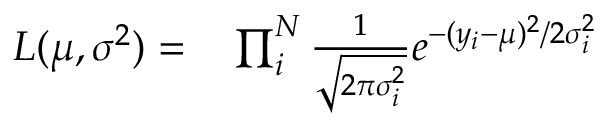<formula> <loc_0><loc_0><loc_500><loc_500>\begin{array} { r l } { L ( \mu , \sigma ^ { 2 } ) = } & \prod _ { i } ^ { N } \frac { 1 } { \sqrt { 2 \pi \sigma _ { i } ^ { 2 } } } e ^ { - ( y _ { i } - \mu ) ^ { 2 } / 2 \sigma _ { i } ^ { 2 } } } \end{array}</formula> 